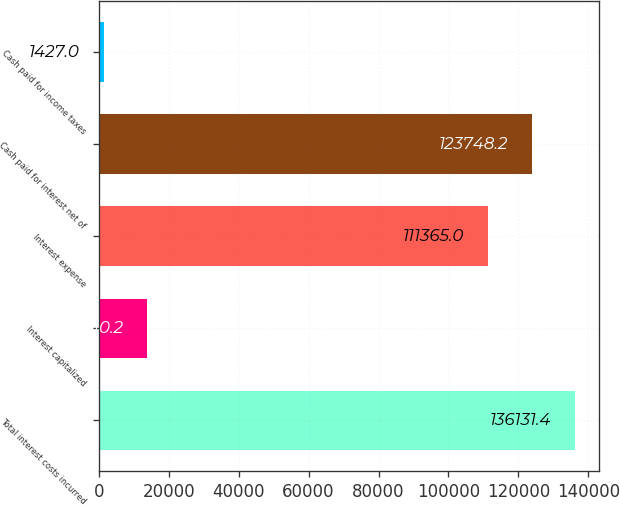<chart> <loc_0><loc_0><loc_500><loc_500><bar_chart><fcel>Total interest costs incurred<fcel>Interest capitalized<fcel>Interest expense<fcel>Cash paid for interest net of<fcel>Cash paid for income taxes<nl><fcel>136131<fcel>13810.2<fcel>111365<fcel>123748<fcel>1427<nl></chart> 